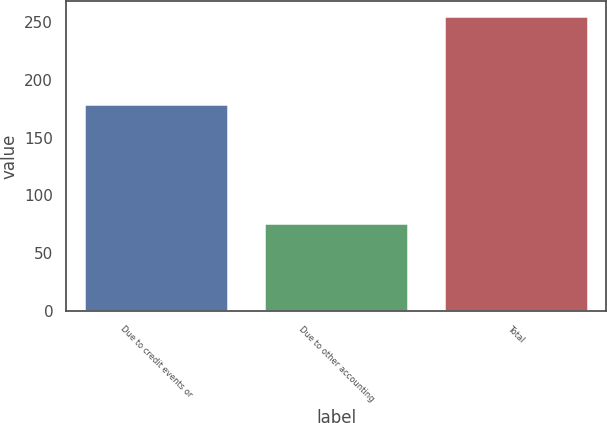Convert chart to OTSL. <chart><loc_0><loc_0><loc_500><loc_500><bar_chart><fcel>Due to credit events or<fcel>Due to other accounting<fcel>Total<nl><fcel>179<fcel>76<fcel>255<nl></chart> 